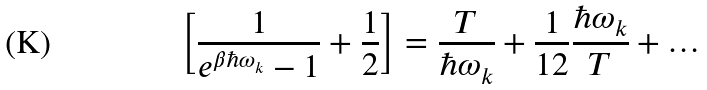<formula> <loc_0><loc_0><loc_500><loc_500>\left [ \frac { 1 } { e ^ { \beta \hbar { \omega } _ { k } } - 1 } + \frac { 1 } { 2 } \right ] = \frac { T } { \hbar { \omega } _ { k } } + \frac { 1 } { 1 2 } \frac { \hbar { \omega } _ { k } } { T } + \dots</formula> 